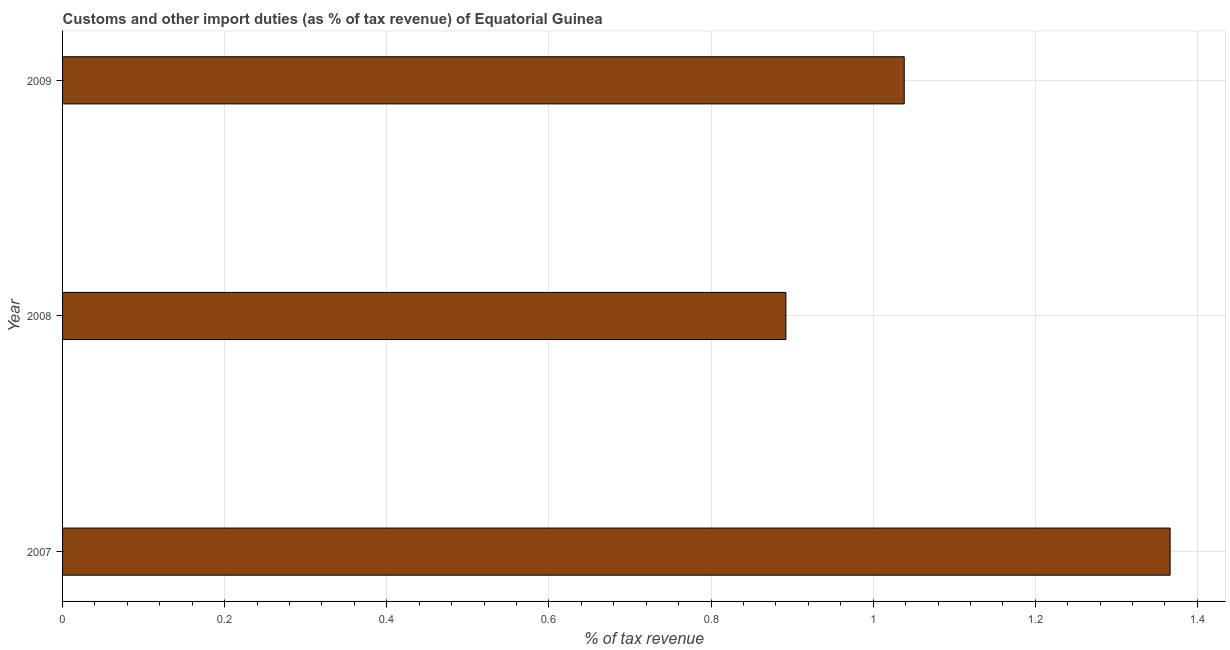Does the graph contain any zero values?
Provide a short and direct response. No. What is the title of the graph?
Ensure brevity in your answer.  Customs and other import duties (as % of tax revenue) of Equatorial Guinea. What is the label or title of the X-axis?
Make the answer very short. % of tax revenue. What is the customs and other import duties in 2009?
Your response must be concise. 1.04. Across all years, what is the maximum customs and other import duties?
Your answer should be compact. 1.37. Across all years, what is the minimum customs and other import duties?
Make the answer very short. 0.89. In which year was the customs and other import duties maximum?
Give a very brief answer. 2007. What is the sum of the customs and other import duties?
Your answer should be compact. 3.3. What is the difference between the customs and other import duties in 2008 and 2009?
Offer a very short reply. -0.15. What is the average customs and other import duties per year?
Your answer should be compact. 1.1. What is the median customs and other import duties?
Provide a short and direct response. 1.04. Do a majority of the years between 2008 and 2007 (inclusive) have customs and other import duties greater than 1.36 %?
Provide a short and direct response. No. What is the ratio of the customs and other import duties in 2007 to that in 2008?
Your response must be concise. 1.53. What is the difference between the highest and the second highest customs and other import duties?
Offer a terse response. 0.33. Is the sum of the customs and other import duties in 2007 and 2009 greater than the maximum customs and other import duties across all years?
Offer a terse response. Yes. What is the difference between the highest and the lowest customs and other import duties?
Ensure brevity in your answer.  0.47. How many bars are there?
Give a very brief answer. 3. Are all the bars in the graph horizontal?
Your answer should be very brief. Yes. Are the values on the major ticks of X-axis written in scientific E-notation?
Your answer should be very brief. No. What is the % of tax revenue in 2007?
Offer a terse response. 1.37. What is the % of tax revenue in 2008?
Provide a short and direct response. 0.89. What is the % of tax revenue in 2009?
Offer a terse response. 1.04. What is the difference between the % of tax revenue in 2007 and 2008?
Offer a terse response. 0.47. What is the difference between the % of tax revenue in 2007 and 2009?
Provide a succinct answer. 0.33. What is the difference between the % of tax revenue in 2008 and 2009?
Give a very brief answer. -0.15. What is the ratio of the % of tax revenue in 2007 to that in 2008?
Offer a very short reply. 1.53. What is the ratio of the % of tax revenue in 2007 to that in 2009?
Keep it short and to the point. 1.32. What is the ratio of the % of tax revenue in 2008 to that in 2009?
Offer a terse response. 0.86. 